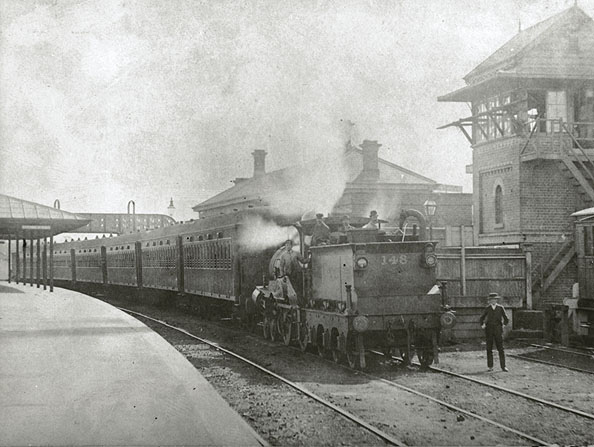Extract all visible text content from this image. 148 